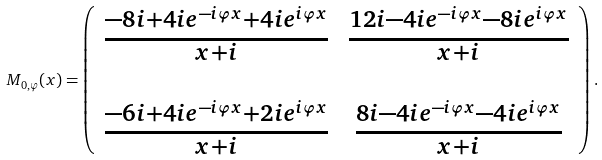<formula> <loc_0><loc_0><loc_500><loc_500>M _ { 0 , \varphi } ( x ) = \left ( \begin{array} { c c } \frac { - 8 i + 4 i e ^ { - i \varphi x } + 4 i e ^ { i \varphi x } } { x + i } & \frac { 1 2 i - 4 i e ^ { - i \varphi x } - 8 i e ^ { i \varphi x } } { x + i } \\ & \\ \frac { - 6 i + 4 i e ^ { - i \varphi x } + 2 i e ^ { i \varphi x } } { x + i } & \frac { 8 i - 4 i e ^ { - i \varphi x } - 4 i e ^ { i \varphi x } } { x + i } \end{array} \right ) .</formula> 